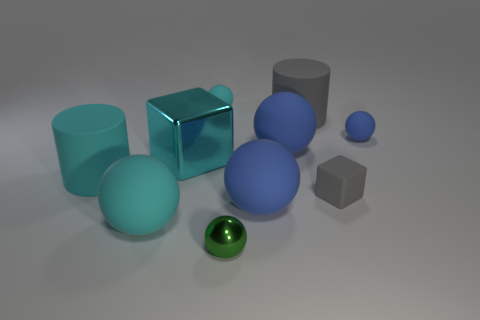Subtract all red cylinders. How many blue spheres are left? 3 Subtract all cyan balls. How many balls are left? 4 Subtract all tiny blue balls. How many balls are left? 5 Subtract all green balls. Subtract all purple cylinders. How many balls are left? 5 Subtract all spheres. How many objects are left? 4 Subtract 1 blue spheres. How many objects are left? 9 Subtract all small brown blocks. Subtract all metallic objects. How many objects are left? 8 Add 8 large cyan blocks. How many large cyan blocks are left? 9 Add 8 big purple metal blocks. How many big purple metal blocks exist? 8 